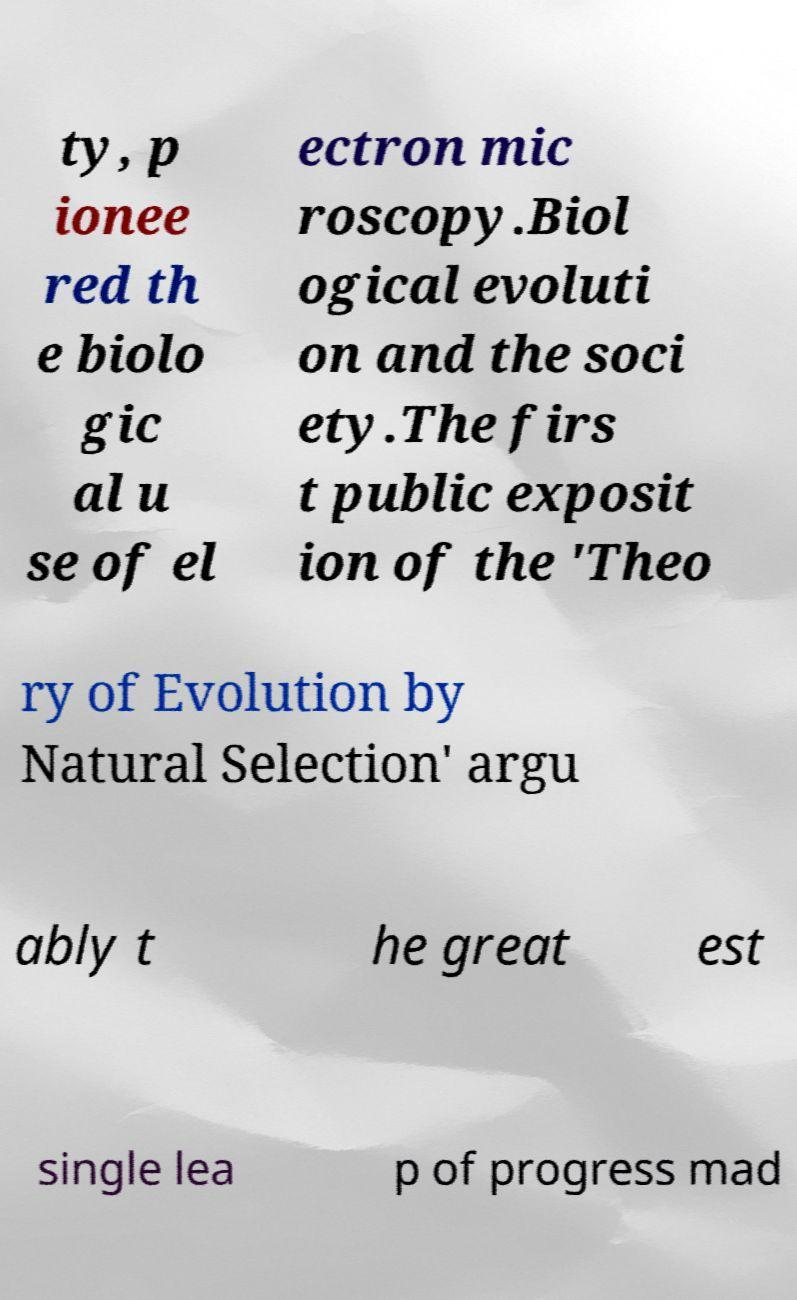For documentation purposes, I need the text within this image transcribed. Could you provide that? ty, p ionee red th e biolo gic al u se of el ectron mic roscopy.Biol ogical evoluti on and the soci ety.The firs t public exposit ion of the 'Theo ry of Evolution by Natural Selection' argu ably t he great est single lea p of progress mad 